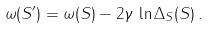<formula> <loc_0><loc_0><loc_500><loc_500>\omega ( S ^ { \prime } ) = \omega ( S ) - 2 \gamma \, \ln \Delta _ { S } ( S ) \, .</formula> 